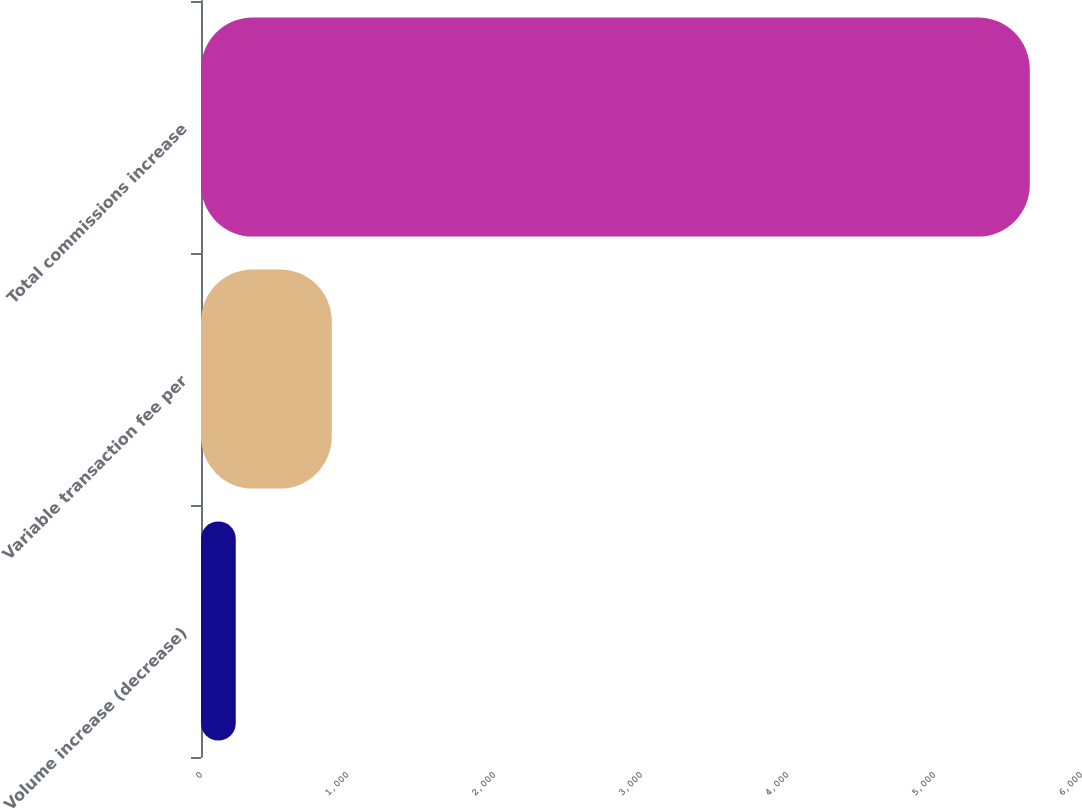Convert chart. <chart><loc_0><loc_0><loc_500><loc_500><bar_chart><fcel>Volume increase (decrease)<fcel>Variable transaction fee per<fcel>Total commissions increase<nl><fcel>237<fcel>892<fcel>5651<nl></chart> 